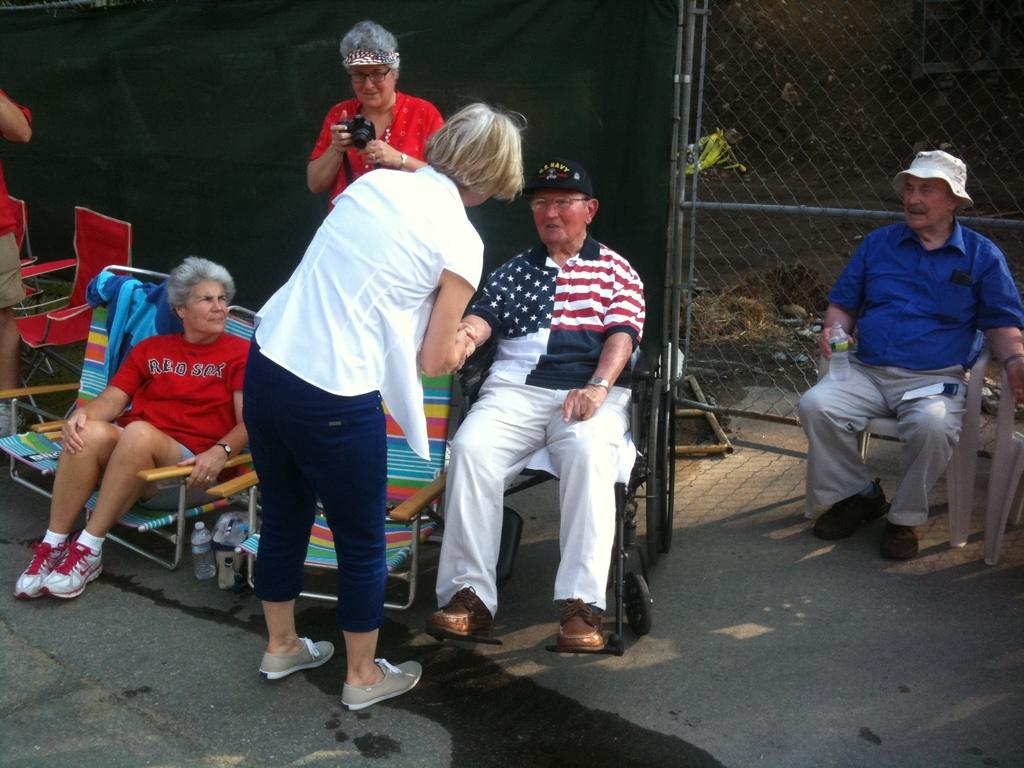What are the people in the image doing? The people in the image are standing and sitting. What can be seen behind the people? There is fencing and cloth visible behind the people. What type of yam is being used as a heart monitor in the image? There is no yam or heart monitor present in the image. 